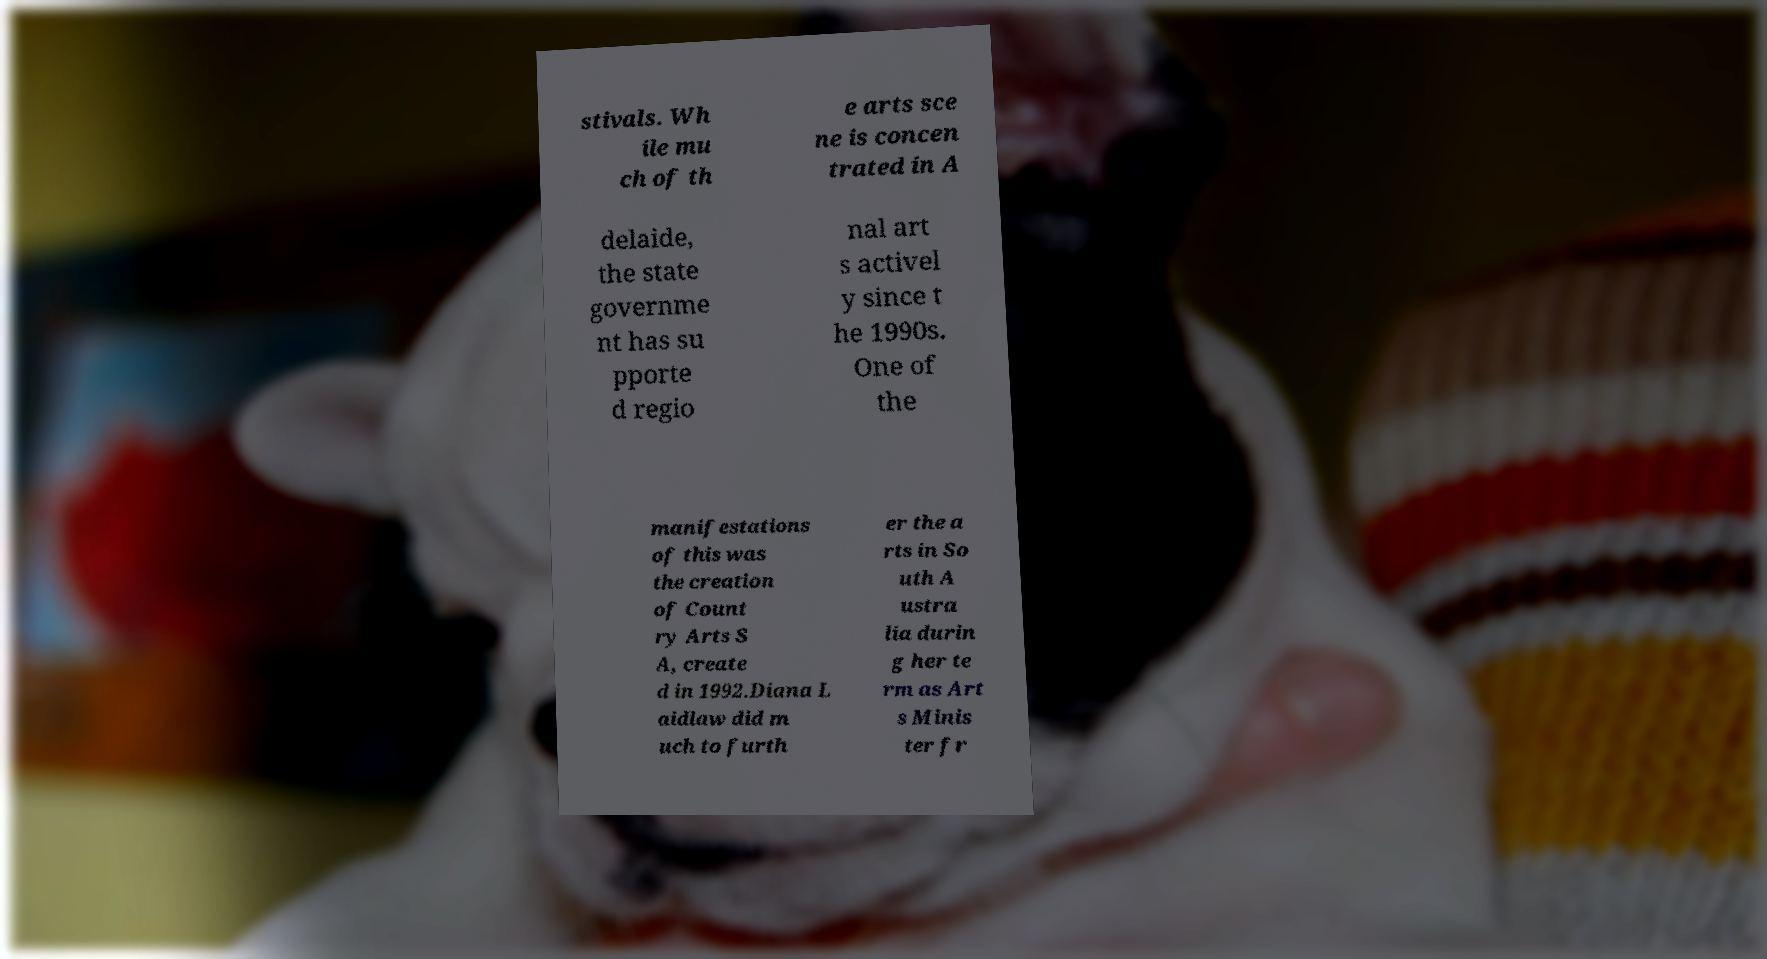Please read and relay the text visible in this image. What does it say? stivals. Wh ile mu ch of th e arts sce ne is concen trated in A delaide, the state governme nt has su pporte d regio nal art s activel y since t he 1990s. One of the manifestations of this was the creation of Count ry Arts S A, create d in 1992.Diana L aidlaw did m uch to furth er the a rts in So uth A ustra lia durin g her te rm as Art s Minis ter fr 